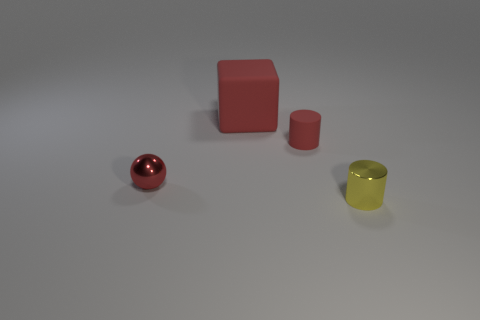How many things are either small objects on the left side of the yellow metal object or yellow metallic cylinders?
Your answer should be compact. 3. Is there a small cyan thing that has the same shape as the small yellow metallic thing?
Your answer should be very brief. No. There is a small yellow metallic thing in front of the small red object that is behind the small sphere; what shape is it?
Your response must be concise. Cylinder. What number of cylinders are either small blue things or red metal things?
Make the answer very short. 0. What is the material of the block that is the same color as the tiny rubber cylinder?
Your response must be concise. Rubber. Do the metal thing that is in front of the metal ball and the tiny metal thing on the left side of the yellow metallic cylinder have the same shape?
Keep it short and to the point. No. There is a thing that is both in front of the tiny red matte cylinder and on the left side of the tiny red rubber cylinder; what is its color?
Provide a succinct answer. Red. Do the sphere and the small metal object to the right of the red metal ball have the same color?
Provide a short and direct response. No. What is the size of the thing that is both behind the small red metal thing and right of the large block?
Provide a succinct answer. Small. How many other things are the same color as the tiny sphere?
Offer a terse response. 2. 